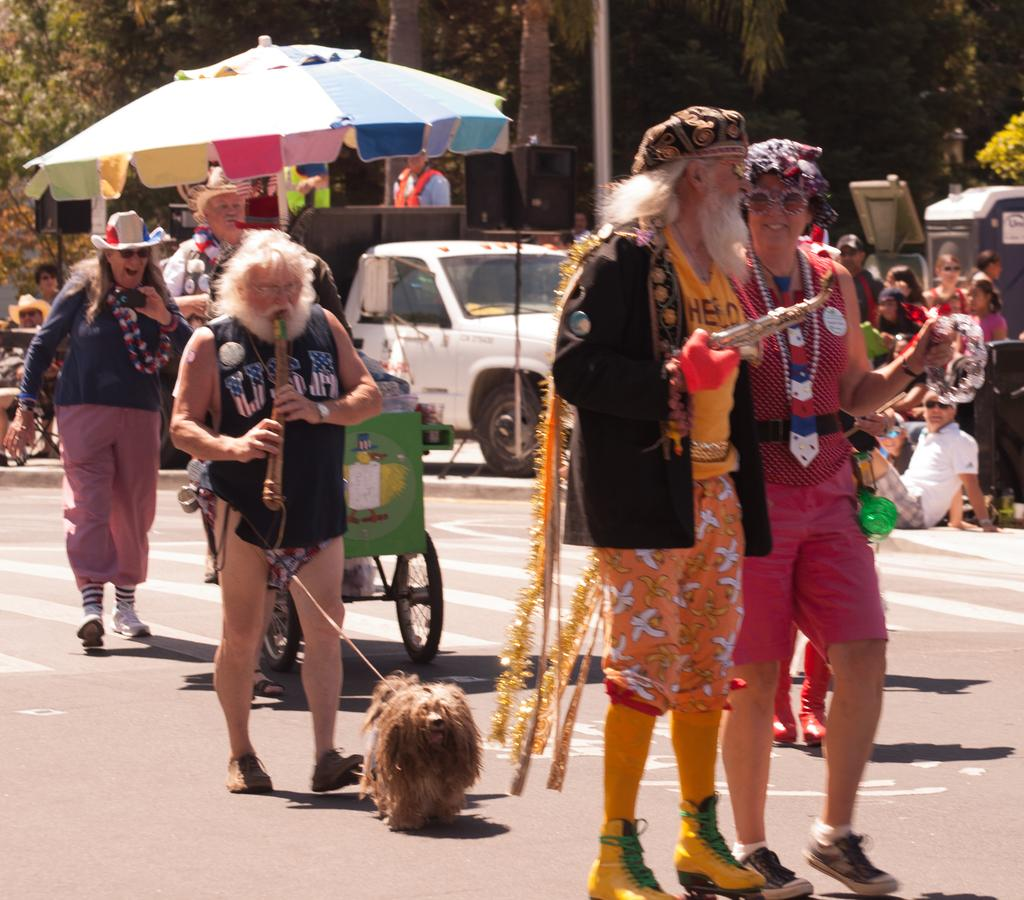What type of vegetation can be seen in the image? There are trees in the image. What vehicles are present in the image? There are trucks in the image. Who or what else can be seen in the image? There are people standing in the image, as well as a dog. What type of weather can be seen in the image? There is no information about the weather in the image; it only shows trees, trucks, people, and a dog. How do the people in the image react to the dog? There is no information about the people's reactions to the dog in the image. 